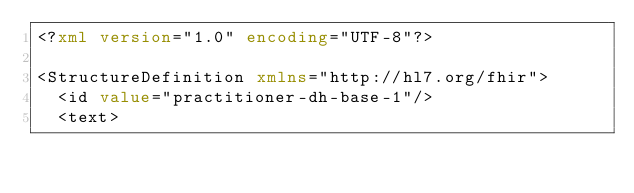<code> <loc_0><loc_0><loc_500><loc_500><_XML_><?xml version="1.0" encoding="UTF-8"?>

<StructureDefinition xmlns="http://hl7.org/fhir">
  <id value="practitioner-dh-base-1"/>
  <text></code> 